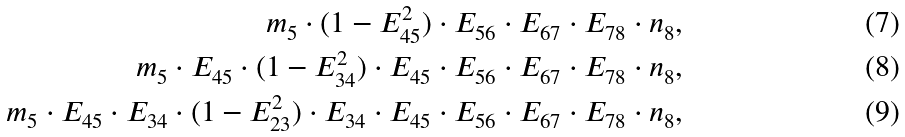Convert formula to latex. <formula><loc_0><loc_0><loc_500><loc_500>m _ { 5 } \cdot ( 1 - E _ { 4 5 } ^ { 2 } ) \cdot E _ { 5 6 } \cdot E _ { 6 7 } \cdot E _ { 7 8 } \cdot n _ { 8 } , \\ m _ { 5 } \cdot E _ { 4 5 } \cdot ( 1 - E _ { 3 4 } ^ { 2 } ) \cdot E _ { 4 5 } \cdot E _ { 5 6 } \cdot E _ { 6 7 } \cdot E _ { 7 8 } \cdot n _ { 8 } , \\ m _ { 5 } \cdot E _ { 4 5 } \cdot E _ { 3 4 } \cdot ( 1 - E _ { 2 3 } ^ { 2 } ) \cdot E _ { 3 4 } \cdot E _ { 4 5 } \cdot E _ { 5 6 } \cdot E _ { 6 7 } \cdot E _ { 7 8 } \cdot n _ { 8 } ,</formula> 